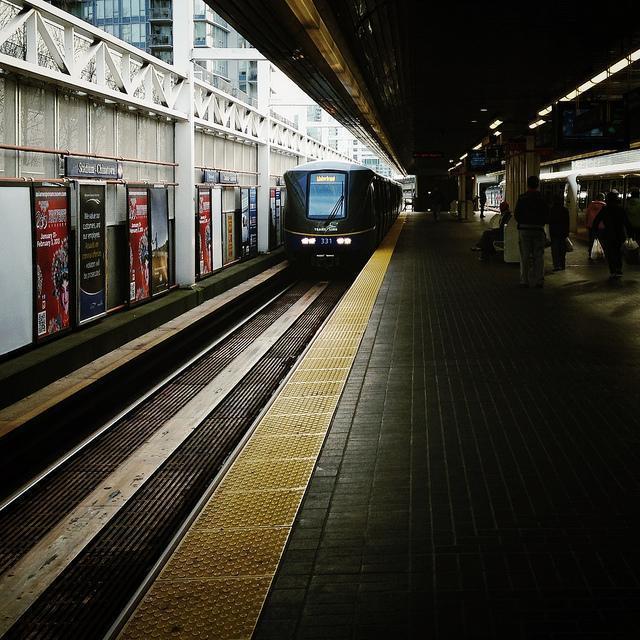What are the colorful posters on the wall used for?
Choose the correct response, then elucidate: 'Answer: answer
Rationale: rationale.'
Options: Targets, advertising, photographing, selling. Answer: advertising.
Rationale: The posters are on the wall in a train station and have products on them. 